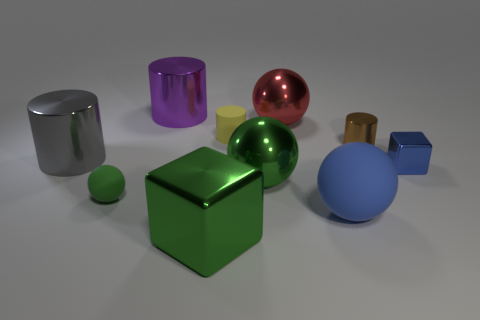How many blue things have the same material as the tiny green sphere?
Offer a terse response. 1. What size is the red thing that is the same shape as the large blue matte object?
Give a very brief answer. Large. Do the gray shiny cylinder and the green rubber thing have the same size?
Keep it short and to the point. No. There is a small metal object behind the cube that is behind the small thing that is to the left of the purple metal cylinder; what is its shape?
Provide a short and direct response. Cylinder. There is another object that is the same shape as the tiny blue metallic object; what color is it?
Offer a very short reply. Green. There is a shiny cylinder that is in front of the big red metallic ball and on the left side of the red metallic object; how big is it?
Your answer should be very brief. Large. What number of shiny spheres are left of the metallic cube that is in front of the shiny block to the right of the big green shiny sphere?
Offer a very short reply. 0. How many tiny things are either blue objects or green metallic things?
Provide a short and direct response. 1. Is the material of the large ball behind the blue metal block the same as the large purple cylinder?
Offer a very short reply. Yes. There is a block that is left of the small cylinder on the right side of the sphere that is behind the tiny yellow cylinder; what is its material?
Provide a succinct answer. Metal. 